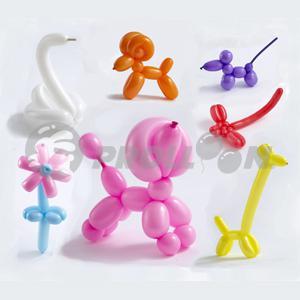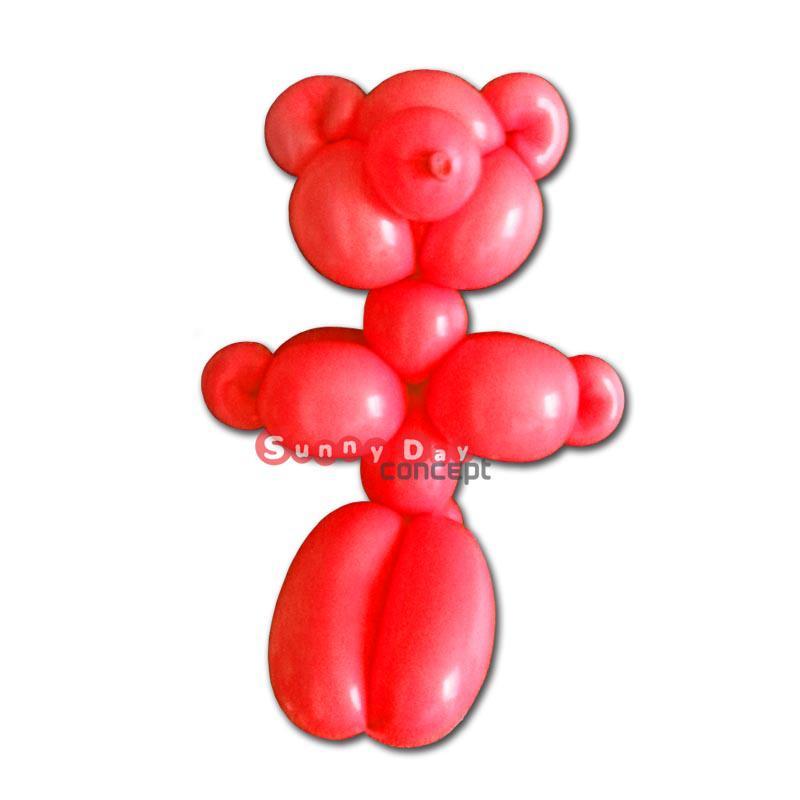The first image is the image on the left, the second image is the image on the right. Evaluate the accuracy of this statement regarding the images: "There are no more than three balloons". Is it true? Answer yes or no. No. 